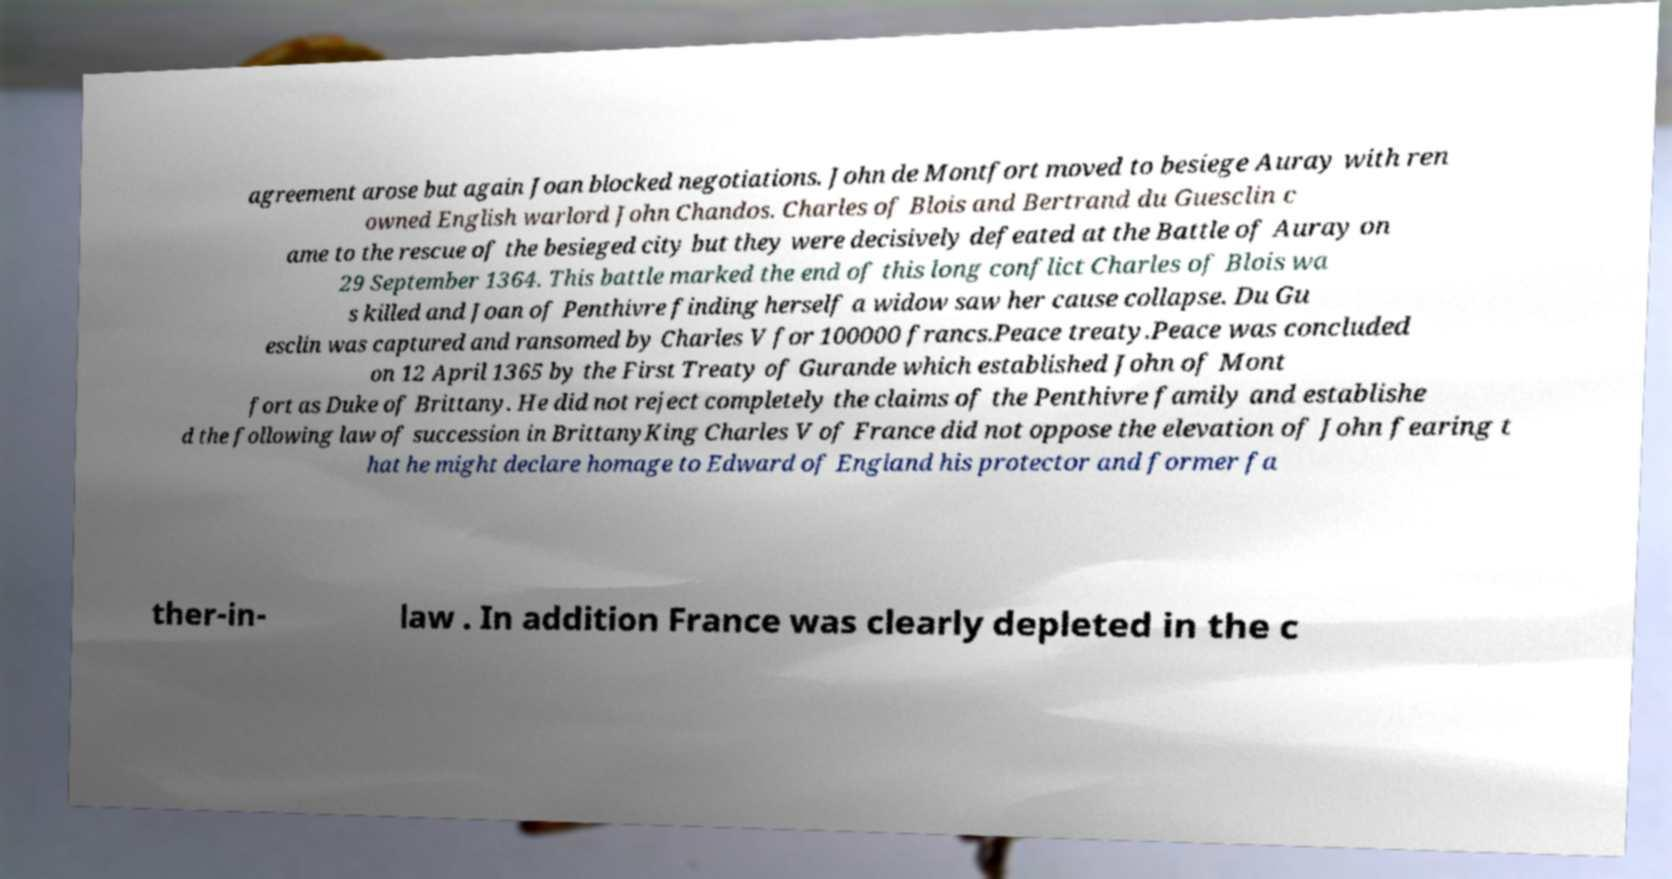There's text embedded in this image that I need extracted. Can you transcribe it verbatim? agreement arose but again Joan blocked negotiations. John de Montfort moved to besiege Auray with ren owned English warlord John Chandos. Charles of Blois and Bertrand du Guesclin c ame to the rescue of the besieged city but they were decisively defeated at the Battle of Auray on 29 September 1364. This battle marked the end of this long conflict Charles of Blois wa s killed and Joan of Penthivre finding herself a widow saw her cause collapse. Du Gu esclin was captured and ransomed by Charles V for 100000 francs.Peace treaty.Peace was concluded on 12 April 1365 by the First Treaty of Gurande which established John of Mont fort as Duke of Brittany. He did not reject completely the claims of the Penthivre family and establishe d the following law of succession in BrittanyKing Charles V of France did not oppose the elevation of John fearing t hat he might declare homage to Edward of England his protector and former fa ther-in- law . In addition France was clearly depleted in the c 